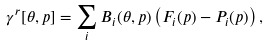<formula> <loc_0><loc_0><loc_500><loc_500>\gamma ^ { r } [ \theta , p ] = \sum _ { i } B _ { i } ( \theta , p ) \left ( F _ { i } ( p ) - P _ { i } ( p ) \right ) ,</formula> 